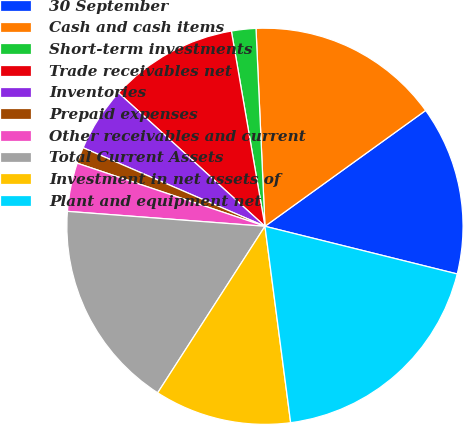Convert chart. <chart><loc_0><loc_0><loc_500><loc_500><pie_chart><fcel>30 September<fcel>Cash and cash items<fcel>Short-term investments<fcel>Trade receivables net<fcel>Inventories<fcel>Prepaid expenses<fcel>Other receivables and current<fcel>Total Current Assets<fcel>Investment in net assets of<fcel>Plant and equipment net<nl><fcel>13.81%<fcel>15.78%<fcel>1.99%<fcel>10.53%<fcel>5.27%<fcel>1.33%<fcel>3.96%<fcel>17.09%<fcel>11.18%<fcel>19.06%<nl></chart> 